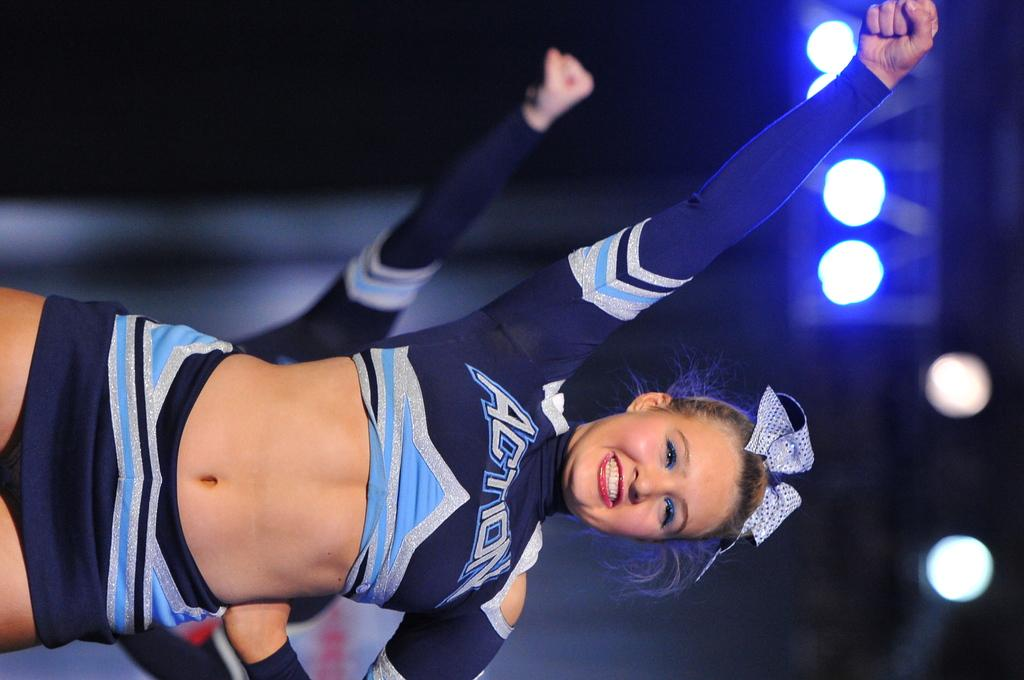What is the woman in the image doing? The woman is standing in the image and smiling. Can you describe the person in the background of the image? Unfortunately, the provided facts do not give any information about the person in the background. What is visible at the top of the image? There are lights visible at the top of the image. What type of animal can be seen swimming in the river in the image? There is no river or animal present in the image. 